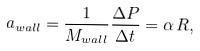Convert formula to latex. <formula><loc_0><loc_0><loc_500><loc_500>a _ { w a l l } = \frac { 1 } { M _ { w a l l } } \frac { \Delta P } { \Delta t } = \alpha \, R ,</formula> 